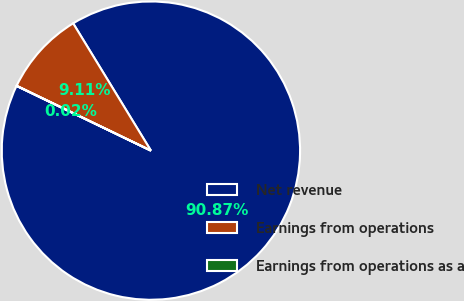<chart> <loc_0><loc_0><loc_500><loc_500><pie_chart><fcel>Net revenue<fcel>Earnings from operations<fcel>Earnings from operations as a<nl><fcel>90.87%<fcel>9.11%<fcel>0.02%<nl></chart> 